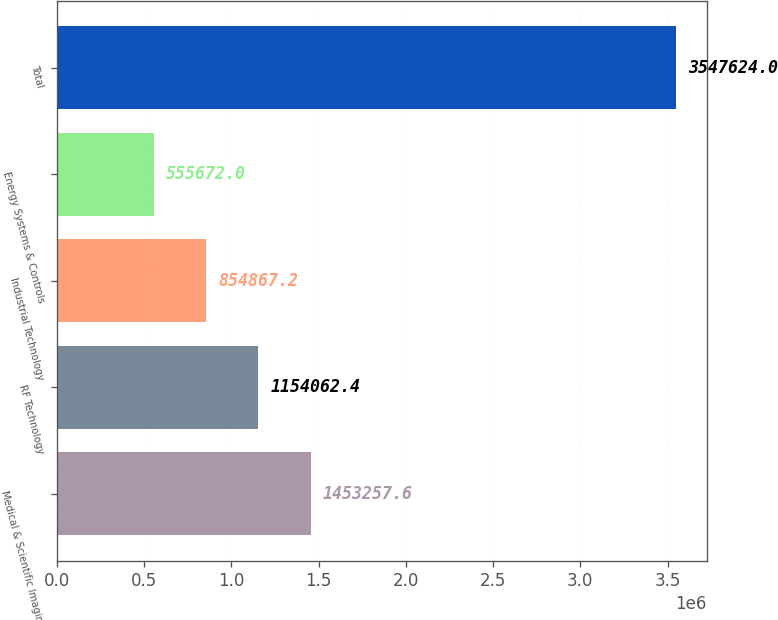Convert chart to OTSL. <chart><loc_0><loc_0><loc_500><loc_500><bar_chart><fcel>Medical & Scientific Imaging<fcel>RF Technology<fcel>Industrial Technology<fcel>Energy Systems & Controls<fcel>Total<nl><fcel>1.45326e+06<fcel>1.15406e+06<fcel>854867<fcel>555672<fcel>3.54762e+06<nl></chart> 